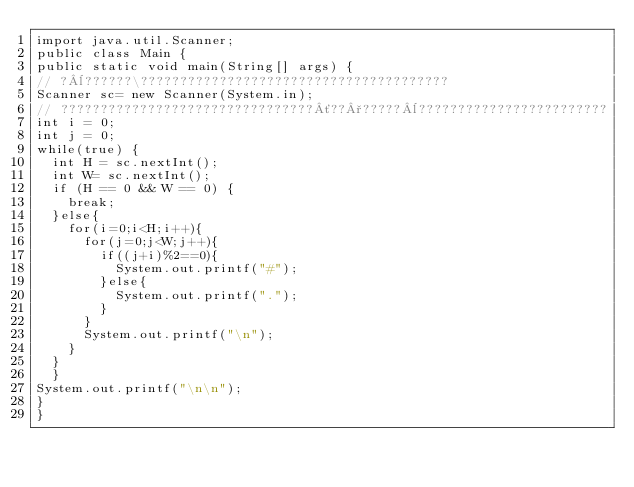<code> <loc_0><loc_0><loc_500><loc_500><_Java_>import java.util.Scanner;
public class Main {
public static void main(String[] args) {
// ?¨??????\???????????????????????????????????????
Scanner sc= new Scanner(System.in);
// ????????????????????????????????´??°?????¨????????????????????????
int i = 0;
int j = 0;
while(true) {
	int H = sc.nextInt();
	int W= sc.nextInt();
	if (H == 0 && W == 0) {
		break;
	}else{
		for(i=0;i<H;i++){
			for(j=0;j<W;j++){
				if((j+i)%2==0){
					System.out.printf("#");
				}else{
					System.out.printf(".");
				}
			}
			System.out.printf("\n");
		}
	}
	}
System.out.printf("\n\n");
}
}</code> 